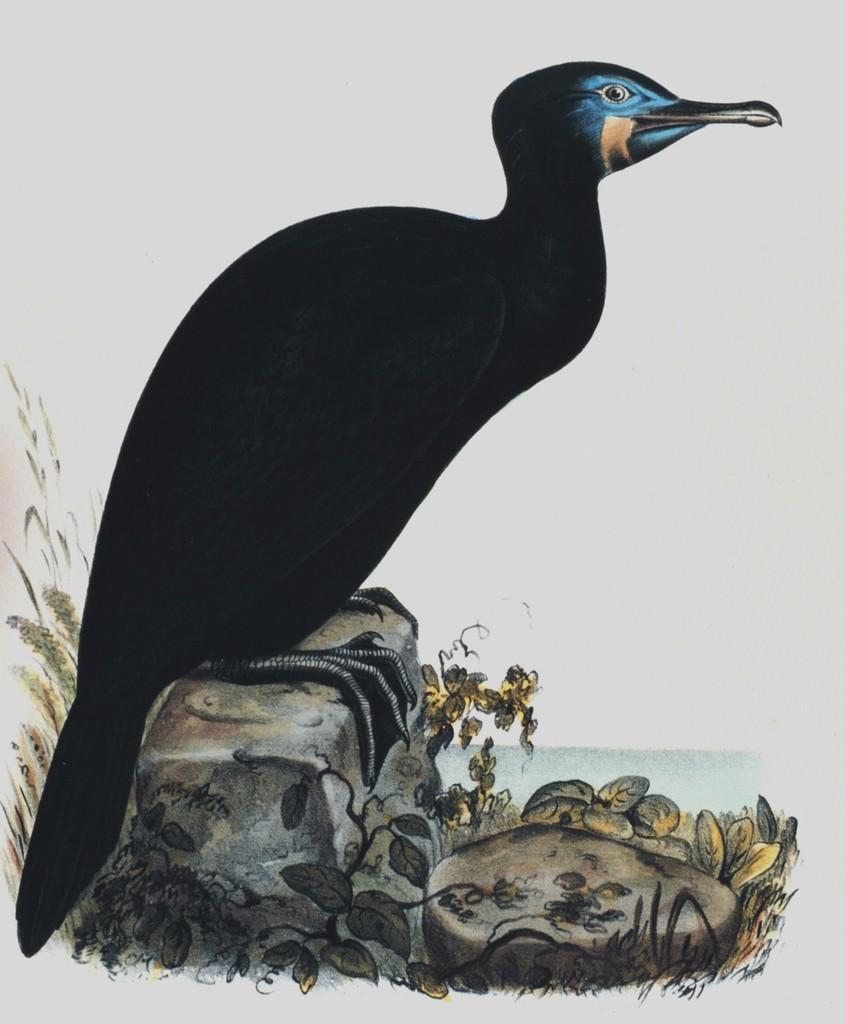What is depicted in the painting in the image? There is a painting of a bird in the image. What is the bird doing in the painting? The bird is standing on rocks in the painting. What else can be seen in the painting besides the bird and rocks? There are plants around the rocks in the painting. What type of lunch is the bird eating in the painting? There is no lunch depicted in the painting; the bird is standing on rocks surrounded by plants. 